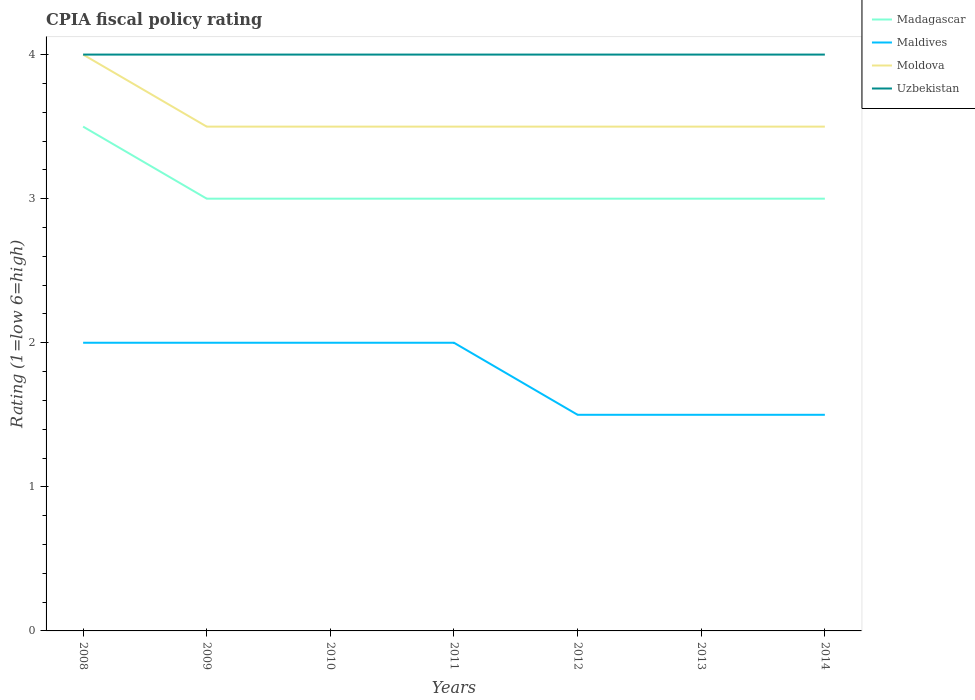Does the line corresponding to Maldives intersect with the line corresponding to Moldova?
Your response must be concise. No. Is the number of lines equal to the number of legend labels?
Provide a short and direct response. Yes. In which year was the CPIA rating in Uzbekistan maximum?
Offer a very short reply. 2008. What is the total CPIA rating in Uzbekistan in the graph?
Your response must be concise. 0. What is the difference between the highest and the lowest CPIA rating in Madagascar?
Ensure brevity in your answer.  1. Is the CPIA rating in Uzbekistan strictly greater than the CPIA rating in Maldives over the years?
Provide a succinct answer. No. What is the difference between two consecutive major ticks on the Y-axis?
Ensure brevity in your answer.  1. Does the graph contain any zero values?
Your answer should be compact. No. Does the graph contain grids?
Keep it short and to the point. No. Where does the legend appear in the graph?
Ensure brevity in your answer.  Top right. How many legend labels are there?
Your answer should be very brief. 4. What is the title of the graph?
Give a very brief answer. CPIA fiscal policy rating. Does "Togo" appear as one of the legend labels in the graph?
Provide a short and direct response. No. What is the label or title of the Y-axis?
Keep it short and to the point. Rating (1=low 6=high). What is the Rating (1=low 6=high) of Maldives in 2008?
Provide a short and direct response. 2. What is the Rating (1=low 6=high) in Uzbekistan in 2008?
Give a very brief answer. 4. What is the Rating (1=low 6=high) of Maldives in 2009?
Your answer should be very brief. 2. What is the Rating (1=low 6=high) of Moldova in 2009?
Your answer should be very brief. 3.5. What is the Rating (1=low 6=high) in Madagascar in 2010?
Keep it short and to the point. 3. What is the Rating (1=low 6=high) in Madagascar in 2011?
Provide a succinct answer. 3. What is the Rating (1=low 6=high) in Moldova in 2011?
Offer a very short reply. 3.5. What is the Rating (1=low 6=high) of Madagascar in 2013?
Keep it short and to the point. 3. What is the Rating (1=low 6=high) of Maldives in 2013?
Offer a terse response. 1.5. What is the Rating (1=low 6=high) of Uzbekistan in 2013?
Ensure brevity in your answer.  4. What is the Rating (1=low 6=high) of Madagascar in 2014?
Your answer should be compact. 3. What is the Rating (1=low 6=high) of Moldova in 2014?
Ensure brevity in your answer.  3.5. What is the Rating (1=low 6=high) in Uzbekistan in 2014?
Your answer should be compact. 4. Across all years, what is the maximum Rating (1=low 6=high) in Moldova?
Offer a terse response. 4. Across all years, what is the maximum Rating (1=low 6=high) of Uzbekistan?
Provide a short and direct response. 4. Across all years, what is the minimum Rating (1=low 6=high) in Moldova?
Ensure brevity in your answer.  3.5. What is the difference between the Rating (1=low 6=high) in Maldives in 2008 and that in 2009?
Your answer should be very brief. 0. What is the difference between the Rating (1=low 6=high) in Moldova in 2008 and that in 2010?
Provide a short and direct response. 0.5. What is the difference between the Rating (1=low 6=high) of Uzbekistan in 2008 and that in 2010?
Provide a succinct answer. 0. What is the difference between the Rating (1=low 6=high) in Madagascar in 2008 and that in 2011?
Make the answer very short. 0.5. What is the difference between the Rating (1=low 6=high) in Maldives in 2008 and that in 2011?
Your response must be concise. 0. What is the difference between the Rating (1=low 6=high) of Uzbekistan in 2008 and that in 2011?
Your answer should be compact. 0. What is the difference between the Rating (1=low 6=high) in Madagascar in 2008 and that in 2012?
Give a very brief answer. 0.5. What is the difference between the Rating (1=low 6=high) of Uzbekistan in 2008 and that in 2012?
Offer a terse response. 0. What is the difference between the Rating (1=low 6=high) of Madagascar in 2008 and that in 2013?
Give a very brief answer. 0.5. What is the difference between the Rating (1=low 6=high) of Moldova in 2008 and that in 2013?
Offer a terse response. 0.5. What is the difference between the Rating (1=low 6=high) of Uzbekistan in 2008 and that in 2013?
Give a very brief answer. 0. What is the difference between the Rating (1=low 6=high) of Madagascar in 2008 and that in 2014?
Provide a succinct answer. 0.5. What is the difference between the Rating (1=low 6=high) in Maldives in 2008 and that in 2014?
Offer a terse response. 0.5. What is the difference between the Rating (1=low 6=high) of Moldova in 2008 and that in 2014?
Make the answer very short. 0.5. What is the difference between the Rating (1=low 6=high) of Madagascar in 2009 and that in 2010?
Ensure brevity in your answer.  0. What is the difference between the Rating (1=low 6=high) in Maldives in 2009 and that in 2011?
Make the answer very short. 0. What is the difference between the Rating (1=low 6=high) of Uzbekistan in 2009 and that in 2011?
Offer a terse response. 0. What is the difference between the Rating (1=low 6=high) of Madagascar in 2009 and that in 2012?
Offer a very short reply. 0. What is the difference between the Rating (1=low 6=high) of Moldova in 2009 and that in 2012?
Ensure brevity in your answer.  0. What is the difference between the Rating (1=low 6=high) of Maldives in 2009 and that in 2013?
Offer a very short reply. 0.5. What is the difference between the Rating (1=low 6=high) in Moldova in 2009 and that in 2013?
Your answer should be compact. 0. What is the difference between the Rating (1=low 6=high) in Madagascar in 2009 and that in 2014?
Your answer should be very brief. 0. What is the difference between the Rating (1=low 6=high) of Uzbekistan in 2009 and that in 2014?
Your answer should be very brief. 0. What is the difference between the Rating (1=low 6=high) in Madagascar in 2010 and that in 2011?
Provide a succinct answer. 0. What is the difference between the Rating (1=low 6=high) of Moldova in 2010 and that in 2011?
Give a very brief answer. 0. What is the difference between the Rating (1=low 6=high) of Maldives in 2010 and that in 2012?
Give a very brief answer. 0.5. What is the difference between the Rating (1=low 6=high) of Moldova in 2010 and that in 2012?
Offer a terse response. 0. What is the difference between the Rating (1=low 6=high) of Moldova in 2010 and that in 2013?
Offer a terse response. 0. What is the difference between the Rating (1=low 6=high) in Uzbekistan in 2010 and that in 2013?
Your answer should be compact. 0. What is the difference between the Rating (1=low 6=high) in Maldives in 2010 and that in 2014?
Offer a terse response. 0.5. What is the difference between the Rating (1=low 6=high) of Moldova in 2010 and that in 2014?
Keep it short and to the point. 0. What is the difference between the Rating (1=low 6=high) in Moldova in 2011 and that in 2012?
Your answer should be very brief. 0. What is the difference between the Rating (1=low 6=high) in Madagascar in 2011 and that in 2013?
Provide a succinct answer. 0. What is the difference between the Rating (1=low 6=high) in Moldova in 2011 and that in 2013?
Give a very brief answer. 0. What is the difference between the Rating (1=low 6=high) of Uzbekistan in 2011 and that in 2013?
Give a very brief answer. 0. What is the difference between the Rating (1=low 6=high) in Maldives in 2011 and that in 2014?
Keep it short and to the point. 0.5. What is the difference between the Rating (1=low 6=high) of Uzbekistan in 2011 and that in 2014?
Ensure brevity in your answer.  0. What is the difference between the Rating (1=low 6=high) in Madagascar in 2012 and that in 2013?
Give a very brief answer. 0. What is the difference between the Rating (1=low 6=high) in Moldova in 2012 and that in 2013?
Offer a terse response. 0. What is the difference between the Rating (1=low 6=high) of Uzbekistan in 2012 and that in 2013?
Offer a terse response. 0. What is the difference between the Rating (1=low 6=high) of Maldives in 2012 and that in 2014?
Offer a very short reply. 0. What is the difference between the Rating (1=low 6=high) of Moldova in 2012 and that in 2014?
Your response must be concise. 0. What is the difference between the Rating (1=low 6=high) of Uzbekistan in 2012 and that in 2014?
Your response must be concise. 0. What is the difference between the Rating (1=low 6=high) in Maldives in 2013 and that in 2014?
Provide a short and direct response. 0. What is the difference between the Rating (1=low 6=high) in Uzbekistan in 2013 and that in 2014?
Offer a very short reply. 0. What is the difference between the Rating (1=low 6=high) of Madagascar in 2008 and the Rating (1=low 6=high) of Maldives in 2009?
Your answer should be very brief. 1.5. What is the difference between the Rating (1=low 6=high) of Madagascar in 2008 and the Rating (1=low 6=high) of Moldova in 2009?
Your answer should be compact. 0. What is the difference between the Rating (1=low 6=high) of Maldives in 2008 and the Rating (1=low 6=high) of Uzbekistan in 2009?
Your answer should be compact. -2. What is the difference between the Rating (1=low 6=high) in Madagascar in 2008 and the Rating (1=low 6=high) in Maldives in 2010?
Keep it short and to the point. 1.5. What is the difference between the Rating (1=low 6=high) in Maldives in 2008 and the Rating (1=low 6=high) in Moldova in 2010?
Your answer should be compact. -1.5. What is the difference between the Rating (1=low 6=high) of Madagascar in 2008 and the Rating (1=low 6=high) of Maldives in 2011?
Ensure brevity in your answer.  1.5. What is the difference between the Rating (1=low 6=high) in Madagascar in 2008 and the Rating (1=low 6=high) in Moldova in 2011?
Offer a very short reply. 0. What is the difference between the Rating (1=low 6=high) in Madagascar in 2008 and the Rating (1=low 6=high) in Uzbekistan in 2011?
Make the answer very short. -0.5. What is the difference between the Rating (1=low 6=high) of Maldives in 2008 and the Rating (1=low 6=high) of Uzbekistan in 2011?
Give a very brief answer. -2. What is the difference between the Rating (1=low 6=high) of Madagascar in 2008 and the Rating (1=low 6=high) of Moldova in 2012?
Keep it short and to the point. 0. What is the difference between the Rating (1=low 6=high) of Madagascar in 2008 and the Rating (1=low 6=high) of Uzbekistan in 2012?
Keep it short and to the point. -0.5. What is the difference between the Rating (1=low 6=high) of Madagascar in 2008 and the Rating (1=low 6=high) of Maldives in 2013?
Your answer should be very brief. 2. What is the difference between the Rating (1=low 6=high) of Madagascar in 2008 and the Rating (1=low 6=high) of Moldova in 2013?
Your answer should be compact. 0. What is the difference between the Rating (1=low 6=high) of Madagascar in 2008 and the Rating (1=low 6=high) of Uzbekistan in 2013?
Provide a succinct answer. -0.5. What is the difference between the Rating (1=low 6=high) in Maldives in 2008 and the Rating (1=low 6=high) in Moldova in 2013?
Your answer should be compact. -1.5. What is the difference between the Rating (1=low 6=high) of Maldives in 2008 and the Rating (1=low 6=high) of Uzbekistan in 2013?
Give a very brief answer. -2. What is the difference between the Rating (1=low 6=high) of Madagascar in 2008 and the Rating (1=low 6=high) of Maldives in 2014?
Offer a very short reply. 2. What is the difference between the Rating (1=low 6=high) in Maldives in 2008 and the Rating (1=low 6=high) in Moldova in 2014?
Your answer should be very brief. -1.5. What is the difference between the Rating (1=low 6=high) in Maldives in 2008 and the Rating (1=low 6=high) in Uzbekistan in 2014?
Offer a terse response. -2. What is the difference between the Rating (1=low 6=high) in Moldova in 2008 and the Rating (1=low 6=high) in Uzbekistan in 2014?
Offer a terse response. 0. What is the difference between the Rating (1=low 6=high) in Madagascar in 2009 and the Rating (1=low 6=high) in Uzbekistan in 2010?
Your response must be concise. -1. What is the difference between the Rating (1=low 6=high) of Maldives in 2009 and the Rating (1=low 6=high) of Uzbekistan in 2010?
Offer a terse response. -2. What is the difference between the Rating (1=low 6=high) of Moldova in 2009 and the Rating (1=low 6=high) of Uzbekistan in 2010?
Ensure brevity in your answer.  -0.5. What is the difference between the Rating (1=low 6=high) in Madagascar in 2009 and the Rating (1=low 6=high) in Maldives in 2011?
Keep it short and to the point. 1. What is the difference between the Rating (1=low 6=high) in Madagascar in 2009 and the Rating (1=low 6=high) in Uzbekistan in 2011?
Offer a terse response. -1. What is the difference between the Rating (1=low 6=high) of Moldova in 2009 and the Rating (1=low 6=high) of Uzbekistan in 2011?
Give a very brief answer. -0.5. What is the difference between the Rating (1=low 6=high) of Madagascar in 2009 and the Rating (1=low 6=high) of Moldova in 2012?
Offer a terse response. -0.5. What is the difference between the Rating (1=low 6=high) of Madagascar in 2009 and the Rating (1=low 6=high) of Uzbekistan in 2012?
Make the answer very short. -1. What is the difference between the Rating (1=low 6=high) of Maldives in 2009 and the Rating (1=low 6=high) of Uzbekistan in 2012?
Offer a terse response. -2. What is the difference between the Rating (1=low 6=high) of Madagascar in 2009 and the Rating (1=low 6=high) of Maldives in 2013?
Provide a succinct answer. 1.5. What is the difference between the Rating (1=low 6=high) of Madagascar in 2009 and the Rating (1=low 6=high) of Uzbekistan in 2013?
Offer a very short reply. -1. What is the difference between the Rating (1=low 6=high) in Maldives in 2009 and the Rating (1=low 6=high) in Uzbekistan in 2013?
Make the answer very short. -2. What is the difference between the Rating (1=low 6=high) in Moldova in 2009 and the Rating (1=low 6=high) in Uzbekistan in 2013?
Your response must be concise. -0.5. What is the difference between the Rating (1=low 6=high) of Madagascar in 2009 and the Rating (1=low 6=high) of Maldives in 2014?
Your answer should be compact. 1.5. What is the difference between the Rating (1=low 6=high) in Madagascar in 2009 and the Rating (1=low 6=high) in Uzbekistan in 2014?
Provide a succinct answer. -1. What is the difference between the Rating (1=low 6=high) in Madagascar in 2010 and the Rating (1=low 6=high) in Maldives in 2011?
Your response must be concise. 1. What is the difference between the Rating (1=low 6=high) of Madagascar in 2010 and the Rating (1=low 6=high) of Uzbekistan in 2011?
Keep it short and to the point. -1. What is the difference between the Rating (1=low 6=high) of Maldives in 2010 and the Rating (1=low 6=high) of Moldova in 2011?
Make the answer very short. -1.5. What is the difference between the Rating (1=low 6=high) in Moldova in 2010 and the Rating (1=low 6=high) in Uzbekistan in 2011?
Ensure brevity in your answer.  -0.5. What is the difference between the Rating (1=low 6=high) in Madagascar in 2010 and the Rating (1=low 6=high) in Moldova in 2012?
Provide a succinct answer. -0.5. What is the difference between the Rating (1=low 6=high) in Madagascar in 2010 and the Rating (1=low 6=high) in Uzbekistan in 2012?
Ensure brevity in your answer.  -1. What is the difference between the Rating (1=low 6=high) of Moldova in 2010 and the Rating (1=low 6=high) of Uzbekistan in 2012?
Offer a very short reply. -0.5. What is the difference between the Rating (1=low 6=high) in Madagascar in 2010 and the Rating (1=low 6=high) in Maldives in 2013?
Your answer should be compact. 1.5. What is the difference between the Rating (1=low 6=high) in Madagascar in 2010 and the Rating (1=low 6=high) in Uzbekistan in 2013?
Make the answer very short. -1. What is the difference between the Rating (1=low 6=high) of Madagascar in 2010 and the Rating (1=low 6=high) of Uzbekistan in 2014?
Your answer should be very brief. -1. What is the difference between the Rating (1=low 6=high) in Maldives in 2010 and the Rating (1=low 6=high) in Moldova in 2014?
Keep it short and to the point. -1.5. What is the difference between the Rating (1=low 6=high) of Maldives in 2010 and the Rating (1=low 6=high) of Uzbekistan in 2014?
Make the answer very short. -2. What is the difference between the Rating (1=low 6=high) of Moldova in 2010 and the Rating (1=low 6=high) of Uzbekistan in 2014?
Offer a terse response. -0.5. What is the difference between the Rating (1=low 6=high) in Moldova in 2011 and the Rating (1=low 6=high) in Uzbekistan in 2012?
Your answer should be very brief. -0.5. What is the difference between the Rating (1=low 6=high) in Madagascar in 2011 and the Rating (1=low 6=high) in Moldova in 2013?
Provide a short and direct response. -0.5. What is the difference between the Rating (1=low 6=high) of Madagascar in 2011 and the Rating (1=low 6=high) of Uzbekistan in 2013?
Make the answer very short. -1. What is the difference between the Rating (1=low 6=high) of Maldives in 2011 and the Rating (1=low 6=high) of Moldova in 2013?
Make the answer very short. -1.5. What is the difference between the Rating (1=low 6=high) of Moldova in 2011 and the Rating (1=low 6=high) of Uzbekistan in 2013?
Keep it short and to the point. -0.5. What is the difference between the Rating (1=low 6=high) of Madagascar in 2011 and the Rating (1=low 6=high) of Moldova in 2014?
Your answer should be compact. -0.5. What is the difference between the Rating (1=low 6=high) in Madagascar in 2011 and the Rating (1=low 6=high) in Uzbekistan in 2014?
Your answer should be very brief. -1. What is the difference between the Rating (1=low 6=high) in Moldova in 2011 and the Rating (1=low 6=high) in Uzbekistan in 2014?
Your response must be concise. -0.5. What is the difference between the Rating (1=low 6=high) of Madagascar in 2012 and the Rating (1=low 6=high) of Maldives in 2013?
Your answer should be very brief. 1.5. What is the difference between the Rating (1=low 6=high) in Madagascar in 2012 and the Rating (1=low 6=high) in Moldova in 2013?
Your answer should be very brief. -0.5. What is the difference between the Rating (1=low 6=high) in Madagascar in 2012 and the Rating (1=low 6=high) in Uzbekistan in 2013?
Your response must be concise. -1. What is the difference between the Rating (1=low 6=high) of Maldives in 2012 and the Rating (1=low 6=high) of Moldova in 2013?
Make the answer very short. -2. What is the difference between the Rating (1=low 6=high) in Maldives in 2012 and the Rating (1=low 6=high) in Uzbekistan in 2013?
Offer a terse response. -2.5. What is the difference between the Rating (1=low 6=high) in Moldova in 2012 and the Rating (1=low 6=high) in Uzbekistan in 2013?
Keep it short and to the point. -0.5. What is the difference between the Rating (1=low 6=high) in Madagascar in 2012 and the Rating (1=low 6=high) in Maldives in 2014?
Give a very brief answer. 1.5. What is the difference between the Rating (1=low 6=high) of Maldives in 2012 and the Rating (1=low 6=high) of Moldova in 2014?
Keep it short and to the point. -2. What is the difference between the Rating (1=low 6=high) of Maldives in 2012 and the Rating (1=low 6=high) of Uzbekistan in 2014?
Ensure brevity in your answer.  -2.5. What is the difference between the Rating (1=low 6=high) of Madagascar in 2013 and the Rating (1=low 6=high) of Maldives in 2014?
Ensure brevity in your answer.  1.5. What is the difference between the Rating (1=low 6=high) in Madagascar in 2013 and the Rating (1=low 6=high) in Moldova in 2014?
Provide a short and direct response. -0.5. What is the difference between the Rating (1=low 6=high) in Maldives in 2013 and the Rating (1=low 6=high) in Moldova in 2014?
Offer a very short reply. -2. What is the average Rating (1=low 6=high) in Madagascar per year?
Offer a very short reply. 3.07. What is the average Rating (1=low 6=high) of Maldives per year?
Offer a very short reply. 1.79. What is the average Rating (1=low 6=high) of Moldova per year?
Ensure brevity in your answer.  3.57. In the year 2008, what is the difference between the Rating (1=low 6=high) of Madagascar and Rating (1=low 6=high) of Moldova?
Provide a short and direct response. -0.5. In the year 2008, what is the difference between the Rating (1=low 6=high) of Madagascar and Rating (1=low 6=high) of Uzbekistan?
Give a very brief answer. -0.5. In the year 2008, what is the difference between the Rating (1=low 6=high) of Moldova and Rating (1=low 6=high) of Uzbekistan?
Make the answer very short. 0. In the year 2009, what is the difference between the Rating (1=low 6=high) of Madagascar and Rating (1=low 6=high) of Moldova?
Ensure brevity in your answer.  -0.5. In the year 2009, what is the difference between the Rating (1=low 6=high) of Madagascar and Rating (1=low 6=high) of Uzbekistan?
Offer a very short reply. -1. In the year 2009, what is the difference between the Rating (1=low 6=high) in Maldives and Rating (1=low 6=high) in Moldova?
Offer a very short reply. -1.5. In the year 2010, what is the difference between the Rating (1=low 6=high) in Madagascar and Rating (1=low 6=high) in Uzbekistan?
Keep it short and to the point. -1. In the year 2010, what is the difference between the Rating (1=low 6=high) of Moldova and Rating (1=low 6=high) of Uzbekistan?
Offer a very short reply. -0.5. In the year 2011, what is the difference between the Rating (1=low 6=high) of Madagascar and Rating (1=low 6=high) of Moldova?
Give a very brief answer. -0.5. In the year 2012, what is the difference between the Rating (1=low 6=high) in Madagascar and Rating (1=low 6=high) in Maldives?
Offer a terse response. 1.5. In the year 2012, what is the difference between the Rating (1=low 6=high) of Madagascar and Rating (1=low 6=high) of Moldova?
Provide a succinct answer. -0.5. In the year 2012, what is the difference between the Rating (1=low 6=high) of Maldives and Rating (1=low 6=high) of Uzbekistan?
Your answer should be very brief. -2.5. In the year 2012, what is the difference between the Rating (1=low 6=high) in Moldova and Rating (1=low 6=high) in Uzbekistan?
Your response must be concise. -0.5. In the year 2013, what is the difference between the Rating (1=low 6=high) of Madagascar and Rating (1=low 6=high) of Maldives?
Give a very brief answer. 1.5. In the year 2013, what is the difference between the Rating (1=low 6=high) in Madagascar and Rating (1=low 6=high) in Moldova?
Offer a very short reply. -0.5. In the year 2013, what is the difference between the Rating (1=low 6=high) of Madagascar and Rating (1=low 6=high) of Uzbekistan?
Make the answer very short. -1. In the year 2013, what is the difference between the Rating (1=low 6=high) of Maldives and Rating (1=low 6=high) of Moldova?
Ensure brevity in your answer.  -2. In the year 2013, what is the difference between the Rating (1=low 6=high) in Moldova and Rating (1=low 6=high) in Uzbekistan?
Give a very brief answer. -0.5. In the year 2014, what is the difference between the Rating (1=low 6=high) of Madagascar and Rating (1=low 6=high) of Moldova?
Keep it short and to the point. -0.5. In the year 2014, what is the difference between the Rating (1=low 6=high) of Madagascar and Rating (1=low 6=high) of Uzbekistan?
Offer a very short reply. -1. In the year 2014, what is the difference between the Rating (1=low 6=high) of Maldives and Rating (1=low 6=high) of Moldova?
Offer a terse response. -2. In the year 2014, what is the difference between the Rating (1=low 6=high) of Maldives and Rating (1=low 6=high) of Uzbekistan?
Give a very brief answer. -2.5. In the year 2014, what is the difference between the Rating (1=low 6=high) of Moldova and Rating (1=low 6=high) of Uzbekistan?
Ensure brevity in your answer.  -0.5. What is the ratio of the Rating (1=low 6=high) of Madagascar in 2008 to that in 2009?
Your response must be concise. 1.17. What is the ratio of the Rating (1=low 6=high) of Uzbekistan in 2008 to that in 2009?
Make the answer very short. 1. What is the ratio of the Rating (1=low 6=high) in Madagascar in 2008 to that in 2010?
Provide a succinct answer. 1.17. What is the ratio of the Rating (1=low 6=high) in Maldives in 2008 to that in 2010?
Keep it short and to the point. 1. What is the ratio of the Rating (1=low 6=high) of Madagascar in 2008 to that in 2011?
Your response must be concise. 1.17. What is the ratio of the Rating (1=low 6=high) in Uzbekistan in 2008 to that in 2011?
Offer a terse response. 1. What is the ratio of the Rating (1=low 6=high) in Maldives in 2008 to that in 2012?
Provide a succinct answer. 1.33. What is the ratio of the Rating (1=low 6=high) in Moldova in 2008 to that in 2012?
Your answer should be compact. 1.14. What is the ratio of the Rating (1=low 6=high) of Uzbekistan in 2008 to that in 2012?
Provide a succinct answer. 1. What is the ratio of the Rating (1=low 6=high) in Maldives in 2008 to that in 2013?
Your answer should be very brief. 1.33. What is the ratio of the Rating (1=low 6=high) of Moldova in 2008 to that in 2013?
Offer a very short reply. 1.14. What is the ratio of the Rating (1=low 6=high) in Uzbekistan in 2008 to that in 2013?
Provide a short and direct response. 1. What is the ratio of the Rating (1=low 6=high) of Maldives in 2008 to that in 2014?
Provide a short and direct response. 1.33. What is the ratio of the Rating (1=low 6=high) in Moldova in 2008 to that in 2014?
Your response must be concise. 1.14. What is the ratio of the Rating (1=low 6=high) in Uzbekistan in 2008 to that in 2014?
Give a very brief answer. 1. What is the ratio of the Rating (1=low 6=high) of Madagascar in 2009 to that in 2010?
Your answer should be very brief. 1. What is the ratio of the Rating (1=low 6=high) in Moldova in 2009 to that in 2010?
Offer a very short reply. 1. What is the ratio of the Rating (1=low 6=high) of Moldova in 2009 to that in 2011?
Give a very brief answer. 1. What is the ratio of the Rating (1=low 6=high) of Uzbekistan in 2009 to that in 2011?
Your response must be concise. 1. What is the ratio of the Rating (1=low 6=high) of Uzbekistan in 2009 to that in 2013?
Provide a short and direct response. 1. What is the ratio of the Rating (1=low 6=high) of Madagascar in 2009 to that in 2014?
Your response must be concise. 1. What is the ratio of the Rating (1=low 6=high) of Maldives in 2009 to that in 2014?
Your answer should be very brief. 1.33. What is the ratio of the Rating (1=low 6=high) in Uzbekistan in 2009 to that in 2014?
Offer a very short reply. 1. What is the ratio of the Rating (1=low 6=high) of Madagascar in 2010 to that in 2011?
Offer a terse response. 1. What is the ratio of the Rating (1=low 6=high) of Maldives in 2010 to that in 2011?
Keep it short and to the point. 1. What is the ratio of the Rating (1=low 6=high) of Moldova in 2010 to that in 2011?
Your answer should be compact. 1. What is the ratio of the Rating (1=low 6=high) in Madagascar in 2010 to that in 2012?
Your answer should be very brief. 1. What is the ratio of the Rating (1=low 6=high) of Maldives in 2010 to that in 2012?
Provide a short and direct response. 1.33. What is the ratio of the Rating (1=low 6=high) in Uzbekistan in 2010 to that in 2012?
Your answer should be very brief. 1. What is the ratio of the Rating (1=low 6=high) in Maldives in 2010 to that in 2013?
Provide a succinct answer. 1.33. What is the ratio of the Rating (1=low 6=high) of Moldova in 2010 to that in 2013?
Keep it short and to the point. 1. What is the ratio of the Rating (1=low 6=high) in Madagascar in 2010 to that in 2014?
Your response must be concise. 1. What is the ratio of the Rating (1=low 6=high) of Moldova in 2010 to that in 2014?
Make the answer very short. 1. What is the ratio of the Rating (1=low 6=high) of Uzbekistan in 2010 to that in 2014?
Make the answer very short. 1. What is the ratio of the Rating (1=low 6=high) in Madagascar in 2011 to that in 2012?
Offer a very short reply. 1. What is the ratio of the Rating (1=low 6=high) in Uzbekistan in 2011 to that in 2012?
Ensure brevity in your answer.  1. What is the ratio of the Rating (1=low 6=high) in Madagascar in 2011 to that in 2013?
Keep it short and to the point. 1. What is the ratio of the Rating (1=low 6=high) of Madagascar in 2011 to that in 2014?
Your response must be concise. 1. What is the ratio of the Rating (1=low 6=high) of Maldives in 2011 to that in 2014?
Provide a succinct answer. 1.33. What is the ratio of the Rating (1=low 6=high) of Maldives in 2012 to that in 2013?
Offer a terse response. 1. What is the ratio of the Rating (1=low 6=high) of Moldova in 2012 to that in 2013?
Make the answer very short. 1. What is the ratio of the Rating (1=low 6=high) in Uzbekistan in 2012 to that in 2013?
Your answer should be compact. 1. What is the ratio of the Rating (1=low 6=high) of Moldova in 2012 to that in 2014?
Your answer should be compact. 1. What is the ratio of the Rating (1=low 6=high) in Uzbekistan in 2012 to that in 2014?
Ensure brevity in your answer.  1. What is the difference between the highest and the second highest Rating (1=low 6=high) of Madagascar?
Your answer should be very brief. 0.5. What is the difference between the highest and the second highest Rating (1=low 6=high) in Maldives?
Offer a very short reply. 0. What is the difference between the highest and the second highest Rating (1=low 6=high) of Moldova?
Your answer should be very brief. 0.5. What is the difference between the highest and the lowest Rating (1=low 6=high) in Uzbekistan?
Give a very brief answer. 0. 